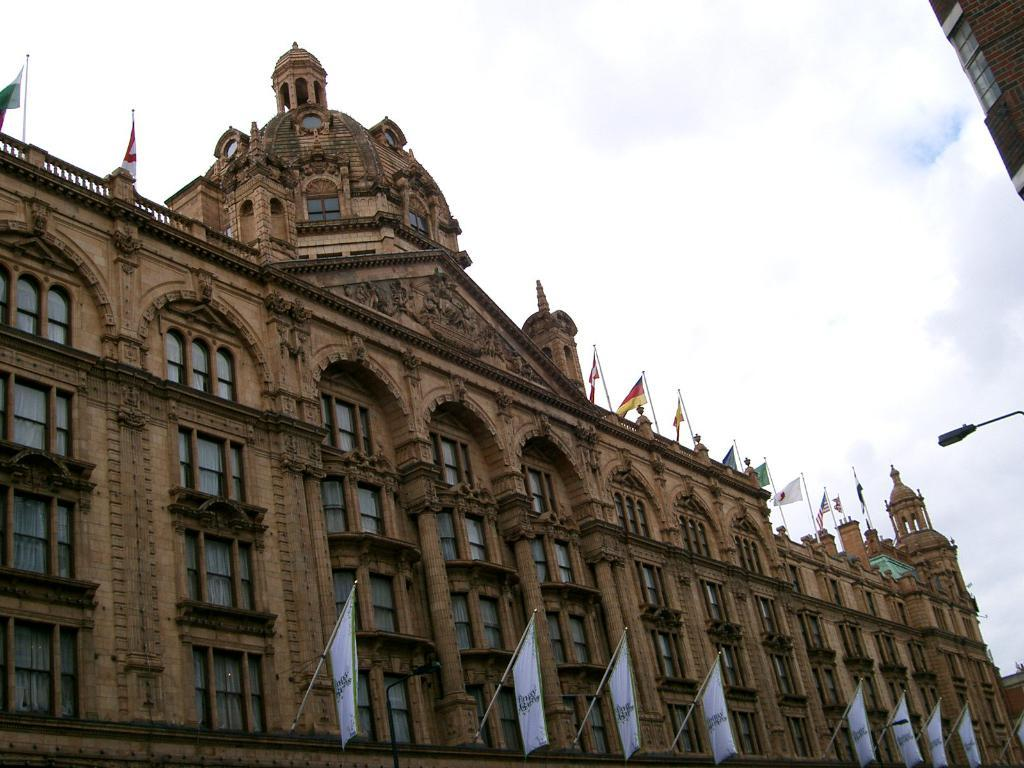What is the main structure in the image? There is a huge building in the image. What features can be seen on the building? The building has beautiful carvings and windows. Where are the flags located on the building? Flags are attached to the pillars of the building and also present on the top of the building. How does the tramp interact with the building in the image? There is no tramp present in the image, so it cannot be determined how a tramp would interact with the building. 